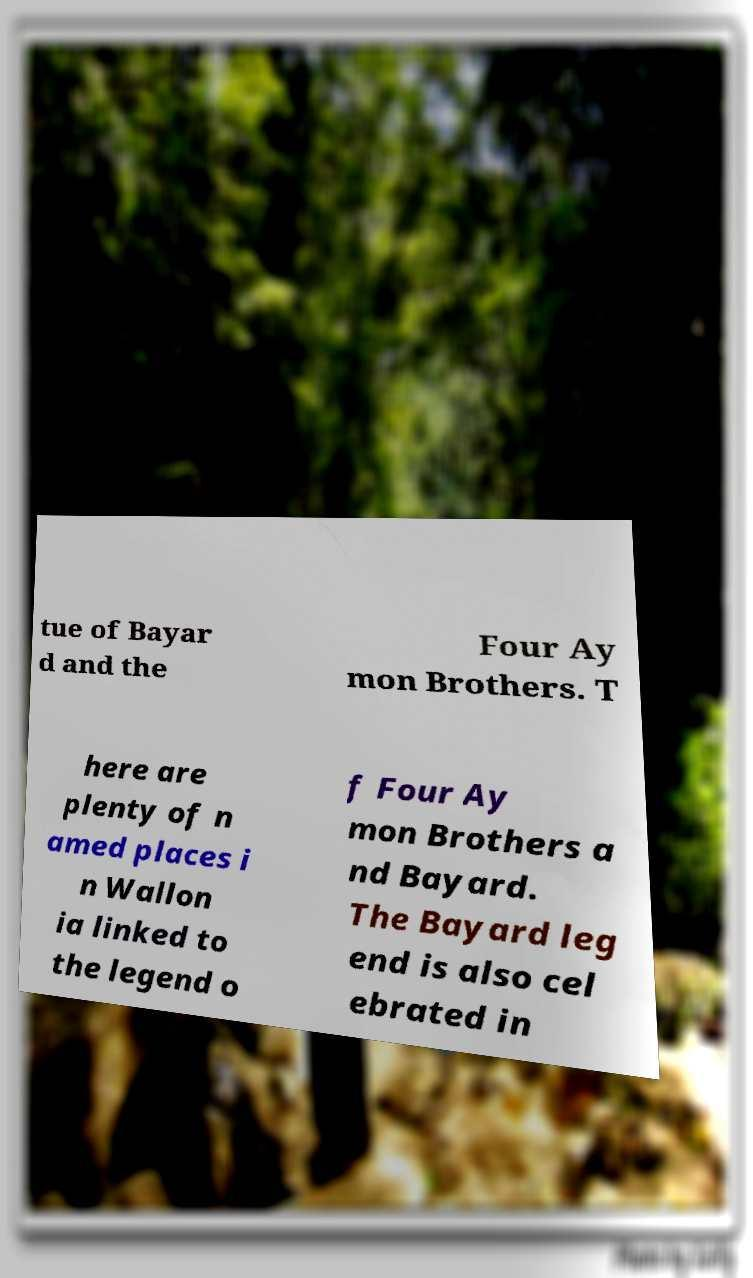Could you assist in decoding the text presented in this image and type it out clearly? tue of Bayar d and the Four Ay mon Brothers. T here are plenty of n amed places i n Wallon ia linked to the legend o f Four Ay mon Brothers a nd Bayard. The Bayard leg end is also cel ebrated in 